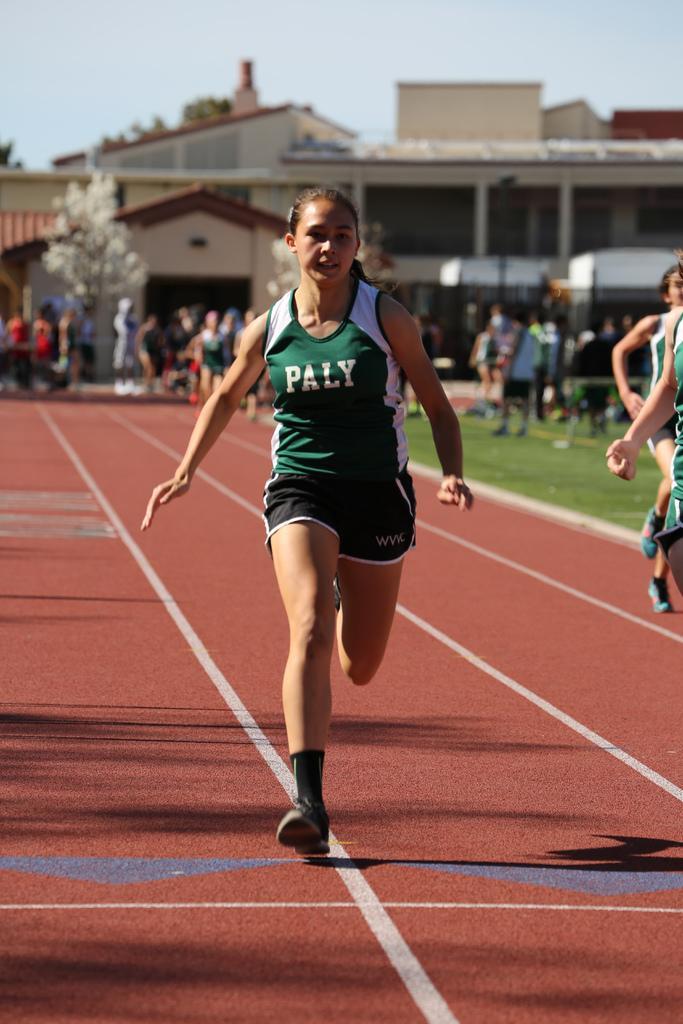In one or two sentences, can you explain what this image depicts? In this image I can see there are persons running on the ground. And few persons are standing. And at the back there is a grass, Trees and building. At the top there is a sky. 